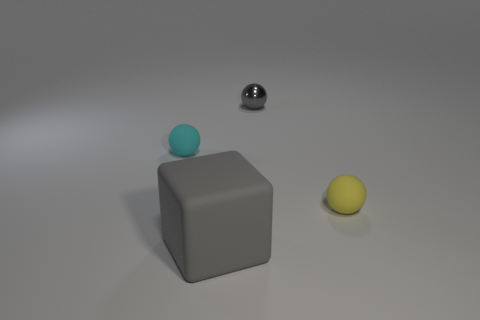Add 2 tiny yellow objects. How many objects exist? 6 Subtract all tiny yellow rubber balls. How many balls are left? 2 Subtract all yellow spheres. How many spheres are left? 2 Subtract all cyan blocks. How many red balls are left? 0 Subtract 0 purple cubes. How many objects are left? 4 Subtract all balls. How many objects are left? 1 Subtract all blue spheres. Subtract all gray cylinders. How many spheres are left? 3 Subtract all large blue spheres. Subtract all yellow rubber spheres. How many objects are left? 3 Add 2 yellow spheres. How many yellow spheres are left? 3 Add 4 rubber blocks. How many rubber blocks exist? 5 